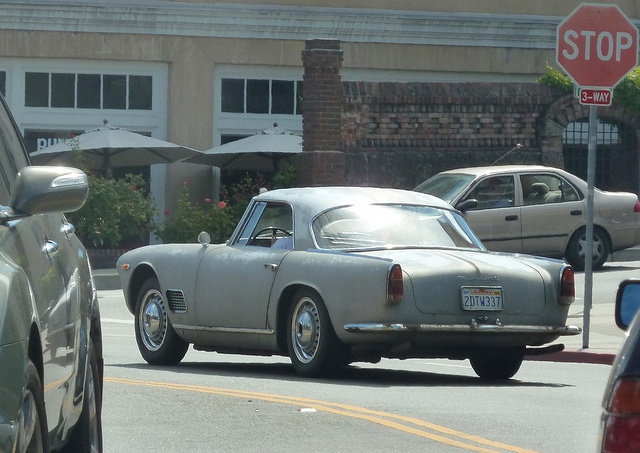Describe the objects in this image and their specific colors. I can see car in gray, black, white, and darkgray tones, car in gray, black, darkgray, and purple tones, car in gray, black, darkgray, and purple tones, stop sign in gray and brown tones, and car in gray, maroon, black, and blue tones in this image. 